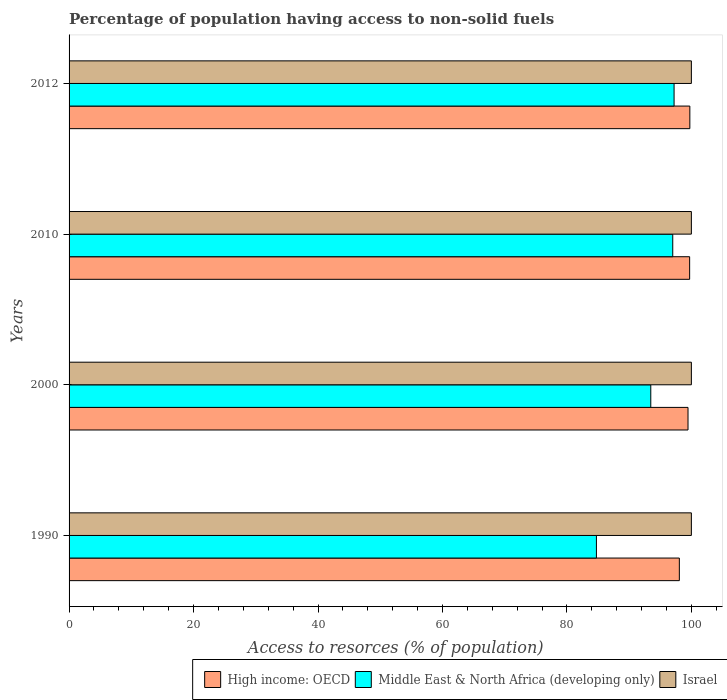How many groups of bars are there?
Provide a succinct answer. 4. Are the number of bars per tick equal to the number of legend labels?
Keep it short and to the point. Yes. How many bars are there on the 1st tick from the top?
Provide a short and direct response. 3. In how many cases, is the number of bars for a given year not equal to the number of legend labels?
Your answer should be compact. 0. What is the percentage of population having access to non-solid fuels in High income: OECD in 2010?
Provide a short and direct response. 99.72. Across all years, what is the maximum percentage of population having access to non-solid fuels in Israel?
Offer a terse response. 100. Across all years, what is the minimum percentage of population having access to non-solid fuels in Middle East & North Africa (developing only)?
Offer a terse response. 84.74. In which year was the percentage of population having access to non-solid fuels in Israel maximum?
Keep it short and to the point. 1990. In which year was the percentage of population having access to non-solid fuels in High income: OECD minimum?
Offer a very short reply. 1990. What is the total percentage of population having access to non-solid fuels in Middle East & North Africa (developing only) in the graph?
Your answer should be compact. 372.44. What is the difference between the percentage of population having access to non-solid fuels in High income: OECD in 2000 and that in 2010?
Your answer should be very brief. -0.26. What is the difference between the percentage of population having access to non-solid fuels in Middle East & North Africa (developing only) in 1990 and the percentage of population having access to non-solid fuels in Israel in 2012?
Your answer should be very brief. -15.26. What is the average percentage of population having access to non-solid fuels in High income: OECD per year?
Your answer should be very brief. 99.25. In the year 2012, what is the difference between the percentage of population having access to non-solid fuels in High income: OECD and percentage of population having access to non-solid fuels in Middle East & North Africa (developing only)?
Make the answer very short. 2.53. What is the ratio of the percentage of population having access to non-solid fuels in High income: OECD in 2000 to that in 2010?
Give a very brief answer. 1. Is the percentage of population having access to non-solid fuels in Israel in 1990 less than that in 2010?
Your answer should be very brief. No. What is the difference between the highest and the second highest percentage of population having access to non-solid fuels in High income: OECD?
Offer a terse response. 0.03. What is the difference between the highest and the lowest percentage of population having access to non-solid fuels in High income: OECD?
Your answer should be compact. 1.69. Is the sum of the percentage of population having access to non-solid fuels in Middle East & North Africa (developing only) in 2010 and 2012 greater than the maximum percentage of population having access to non-solid fuels in High income: OECD across all years?
Ensure brevity in your answer.  Yes. What does the 1st bar from the top in 2010 represents?
Provide a succinct answer. Israel. What does the 3rd bar from the bottom in 2000 represents?
Provide a succinct answer. Israel. Is it the case that in every year, the sum of the percentage of population having access to non-solid fuels in High income: OECD and percentage of population having access to non-solid fuels in Middle East & North Africa (developing only) is greater than the percentage of population having access to non-solid fuels in Israel?
Ensure brevity in your answer.  Yes. How many bars are there?
Ensure brevity in your answer.  12. Are all the bars in the graph horizontal?
Ensure brevity in your answer.  Yes. How many years are there in the graph?
Your response must be concise. 4. What is the title of the graph?
Your answer should be very brief. Percentage of population having access to non-solid fuels. Does "Mozambique" appear as one of the legend labels in the graph?
Provide a succinct answer. No. What is the label or title of the X-axis?
Make the answer very short. Access to resorces (% of population). What is the label or title of the Y-axis?
Ensure brevity in your answer.  Years. What is the Access to resorces (% of population) in High income: OECD in 1990?
Provide a succinct answer. 98.07. What is the Access to resorces (% of population) of Middle East & North Africa (developing only) in 1990?
Keep it short and to the point. 84.74. What is the Access to resorces (% of population) of High income: OECD in 2000?
Give a very brief answer. 99.46. What is the Access to resorces (% of population) of Middle East & North Africa (developing only) in 2000?
Make the answer very short. 93.48. What is the Access to resorces (% of population) of High income: OECD in 2010?
Your answer should be very brief. 99.72. What is the Access to resorces (% of population) in Middle East & North Africa (developing only) in 2010?
Make the answer very short. 97.01. What is the Access to resorces (% of population) in Israel in 2010?
Ensure brevity in your answer.  100. What is the Access to resorces (% of population) in High income: OECD in 2012?
Your answer should be very brief. 99.75. What is the Access to resorces (% of population) in Middle East & North Africa (developing only) in 2012?
Keep it short and to the point. 97.22. Across all years, what is the maximum Access to resorces (% of population) of High income: OECD?
Offer a very short reply. 99.75. Across all years, what is the maximum Access to resorces (% of population) of Middle East & North Africa (developing only)?
Make the answer very short. 97.22. Across all years, what is the maximum Access to resorces (% of population) in Israel?
Keep it short and to the point. 100. Across all years, what is the minimum Access to resorces (% of population) in High income: OECD?
Offer a terse response. 98.07. Across all years, what is the minimum Access to resorces (% of population) in Middle East & North Africa (developing only)?
Your response must be concise. 84.74. Across all years, what is the minimum Access to resorces (% of population) in Israel?
Give a very brief answer. 100. What is the total Access to resorces (% of population) of High income: OECD in the graph?
Ensure brevity in your answer.  397. What is the total Access to resorces (% of population) of Middle East & North Africa (developing only) in the graph?
Offer a very short reply. 372.44. What is the total Access to resorces (% of population) in Israel in the graph?
Make the answer very short. 400. What is the difference between the Access to resorces (% of population) in High income: OECD in 1990 and that in 2000?
Your response must be concise. -1.39. What is the difference between the Access to resorces (% of population) in Middle East & North Africa (developing only) in 1990 and that in 2000?
Offer a very short reply. -8.73. What is the difference between the Access to resorces (% of population) in High income: OECD in 1990 and that in 2010?
Offer a terse response. -1.65. What is the difference between the Access to resorces (% of population) of Middle East & North Africa (developing only) in 1990 and that in 2010?
Make the answer very short. -12.27. What is the difference between the Access to resorces (% of population) in High income: OECD in 1990 and that in 2012?
Your answer should be very brief. -1.69. What is the difference between the Access to resorces (% of population) in Middle East & North Africa (developing only) in 1990 and that in 2012?
Your answer should be very brief. -12.48. What is the difference between the Access to resorces (% of population) of High income: OECD in 2000 and that in 2010?
Your response must be concise. -0.26. What is the difference between the Access to resorces (% of population) of Middle East & North Africa (developing only) in 2000 and that in 2010?
Offer a very short reply. -3.53. What is the difference between the Access to resorces (% of population) in High income: OECD in 2000 and that in 2012?
Provide a short and direct response. -0.29. What is the difference between the Access to resorces (% of population) in Middle East & North Africa (developing only) in 2000 and that in 2012?
Provide a succinct answer. -3.74. What is the difference between the Access to resorces (% of population) in Israel in 2000 and that in 2012?
Your answer should be very brief. 0. What is the difference between the Access to resorces (% of population) of High income: OECD in 2010 and that in 2012?
Give a very brief answer. -0.03. What is the difference between the Access to resorces (% of population) in Middle East & North Africa (developing only) in 2010 and that in 2012?
Provide a succinct answer. -0.21. What is the difference between the Access to resorces (% of population) of High income: OECD in 1990 and the Access to resorces (% of population) of Middle East & North Africa (developing only) in 2000?
Give a very brief answer. 4.59. What is the difference between the Access to resorces (% of population) in High income: OECD in 1990 and the Access to resorces (% of population) in Israel in 2000?
Make the answer very short. -1.93. What is the difference between the Access to resorces (% of population) in Middle East & North Africa (developing only) in 1990 and the Access to resorces (% of population) in Israel in 2000?
Provide a short and direct response. -15.26. What is the difference between the Access to resorces (% of population) of High income: OECD in 1990 and the Access to resorces (% of population) of Middle East & North Africa (developing only) in 2010?
Your answer should be very brief. 1.06. What is the difference between the Access to resorces (% of population) in High income: OECD in 1990 and the Access to resorces (% of population) in Israel in 2010?
Your answer should be very brief. -1.93. What is the difference between the Access to resorces (% of population) of Middle East & North Africa (developing only) in 1990 and the Access to resorces (% of population) of Israel in 2010?
Your answer should be very brief. -15.26. What is the difference between the Access to resorces (% of population) of High income: OECD in 1990 and the Access to resorces (% of population) of Middle East & North Africa (developing only) in 2012?
Your answer should be very brief. 0.85. What is the difference between the Access to resorces (% of population) of High income: OECD in 1990 and the Access to resorces (% of population) of Israel in 2012?
Offer a very short reply. -1.93. What is the difference between the Access to resorces (% of population) in Middle East & North Africa (developing only) in 1990 and the Access to resorces (% of population) in Israel in 2012?
Your response must be concise. -15.26. What is the difference between the Access to resorces (% of population) of High income: OECD in 2000 and the Access to resorces (% of population) of Middle East & North Africa (developing only) in 2010?
Provide a short and direct response. 2.45. What is the difference between the Access to resorces (% of population) in High income: OECD in 2000 and the Access to resorces (% of population) in Israel in 2010?
Your answer should be very brief. -0.54. What is the difference between the Access to resorces (% of population) of Middle East & North Africa (developing only) in 2000 and the Access to resorces (% of population) of Israel in 2010?
Ensure brevity in your answer.  -6.52. What is the difference between the Access to resorces (% of population) in High income: OECD in 2000 and the Access to resorces (% of population) in Middle East & North Africa (developing only) in 2012?
Provide a succinct answer. 2.24. What is the difference between the Access to resorces (% of population) of High income: OECD in 2000 and the Access to resorces (% of population) of Israel in 2012?
Your response must be concise. -0.54. What is the difference between the Access to resorces (% of population) in Middle East & North Africa (developing only) in 2000 and the Access to resorces (% of population) in Israel in 2012?
Your answer should be compact. -6.52. What is the difference between the Access to resorces (% of population) of High income: OECD in 2010 and the Access to resorces (% of population) of Middle East & North Africa (developing only) in 2012?
Your response must be concise. 2.5. What is the difference between the Access to resorces (% of population) of High income: OECD in 2010 and the Access to resorces (% of population) of Israel in 2012?
Ensure brevity in your answer.  -0.28. What is the difference between the Access to resorces (% of population) in Middle East & North Africa (developing only) in 2010 and the Access to resorces (% of population) in Israel in 2012?
Ensure brevity in your answer.  -2.99. What is the average Access to resorces (% of population) in High income: OECD per year?
Offer a very short reply. 99.25. What is the average Access to resorces (% of population) of Middle East & North Africa (developing only) per year?
Ensure brevity in your answer.  93.11. What is the average Access to resorces (% of population) in Israel per year?
Your answer should be compact. 100. In the year 1990, what is the difference between the Access to resorces (% of population) of High income: OECD and Access to resorces (% of population) of Middle East & North Africa (developing only)?
Ensure brevity in your answer.  13.33. In the year 1990, what is the difference between the Access to resorces (% of population) of High income: OECD and Access to resorces (% of population) of Israel?
Give a very brief answer. -1.93. In the year 1990, what is the difference between the Access to resorces (% of population) in Middle East & North Africa (developing only) and Access to resorces (% of population) in Israel?
Ensure brevity in your answer.  -15.26. In the year 2000, what is the difference between the Access to resorces (% of population) of High income: OECD and Access to resorces (% of population) of Middle East & North Africa (developing only)?
Offer a very short reply. 5.99. In the year 2000, what is the difference between the Access to resorces (% of population) in High income: OECD and Access to resorces (% of population) in Israel?
Your answer should be very brief. -0.54. In the year 2000, what is the difference between the Access to resorces (% of population) of Middle East & North Africa (developing only) and Access to resorces (% of population) of Israel?
Offer a very short reply. -6.52. In the year 2010, what is the difference between the Access to resorces (% of population) of High income: OECD and Access to resorces (% of population) of Middle East & North Africa (developing only)?
Make the answer very short. 2.71. In the year 2010, what is the difference between the Access to resorces (% of population) in High income: OECD and Access to resorces (% of population) in Israel?
Keep it short and to the point. -0.28. In the year 2010, what is the difference between the Access to resorces (% of population) in Middle East & North Africa (developing only) and Access to resorces (% of population) in Israel?
Offer a very short reply. -2.99. In the year 2012, what is the difference between the Access to resorces (% of population) in High income: OECD and Access to resorces (% of population) in Middle East & North Africa (developing only)?
Make the answer very short. 2.53. In the year 2012, what is the difference between the Access to resorces (% of population) of High income: OECD and Access to resorces (% of population) of Israel?
Your response must be concise. -0.25. In the year 2012, what is the difference between the Access to resorces (% of population) in Middle East & North Africa (developing only) and Access to resorces (% of population) in Israel?
Your response must be concise. -2.78. What is the ratio of the Access to resorces (% of population) of High income: OECD in 1990 to that in 2000?
Keep it short and to the point. 0.99. What is the ratio of the Access to resorces (% of population) in Middle East & North Africa (developing only) in 1990 to that in 2000?
Your answer should be very brief. 0.91. What is the ratio of the Access to resorces (% of population) of High income: OECD in 1990 to that in 2010?
Give a very brief answer. 0.98. What is the ratio of the Access to resorces (% of population) in Middle East & North Africa (developing only) in 1990 to that in 2010?
Offer a very short reply. 0.87. What is the ratio of the Access to resorces (% of population) of High income: OECD in 1990 to that in 2012?
Offer a terse response. 0.98. What is the ratio of the Access to resorces (% of population) in Middle East & North Africa (developing only) in 1990 to that in 2012?
Your answer should be very brief. 0.87. What is the ratio of the Access to resorces (% of population) of High income: OECD in 2000 to that in 2010?
Offer a very short reply. 1. What is the ratio of the Access to resorces (% of population) of Middle East & North Africa (developing only) in 2000 to that in 2010?
Offer a very short reply. 0.96. What is the ratio of the Access to resorces (% of population) in Israel in 2000 to that in 2010?
Your answer should be very brief. 1. What is the ratio of the Access to resorces (% of population) in High income: OECD in 2000 to that in 2012?
Provide a succinct answer. 1. What is the ratio of the Access to resorces (% of population) in Middle East & North Africa (developing only) in 2000 to that in 2012?
Your answer should be very brief. 0.96. What is the ratio of the Access to resorces (% of population) in Israel in 2000 to that in 2012?
Make the answer very short. 1. What is the difference between the highest and the second highest Access to resorces (% of population) in High income: OECD?
Your answer should be very brief. 0.03. What is the difference between the highest and the second highest Access to resorces (% of population) in Middle East & North Africa (developing only)?
Ensure brevity in your answer.  0.21. What is the difference between the highest and the second highest Access to resorces (% of population) of Israel?
Offer a very short reply. 0. What is the difference between the highest and the lowest Access to resorces (% of population) of High income: OECD?
Offer a very short reply. 1.69. What is the difference between the highest and the lowest Access to resorces (% of population) in Middle East & North Africa (developing only)?
Your response must be concise. 12.48. 